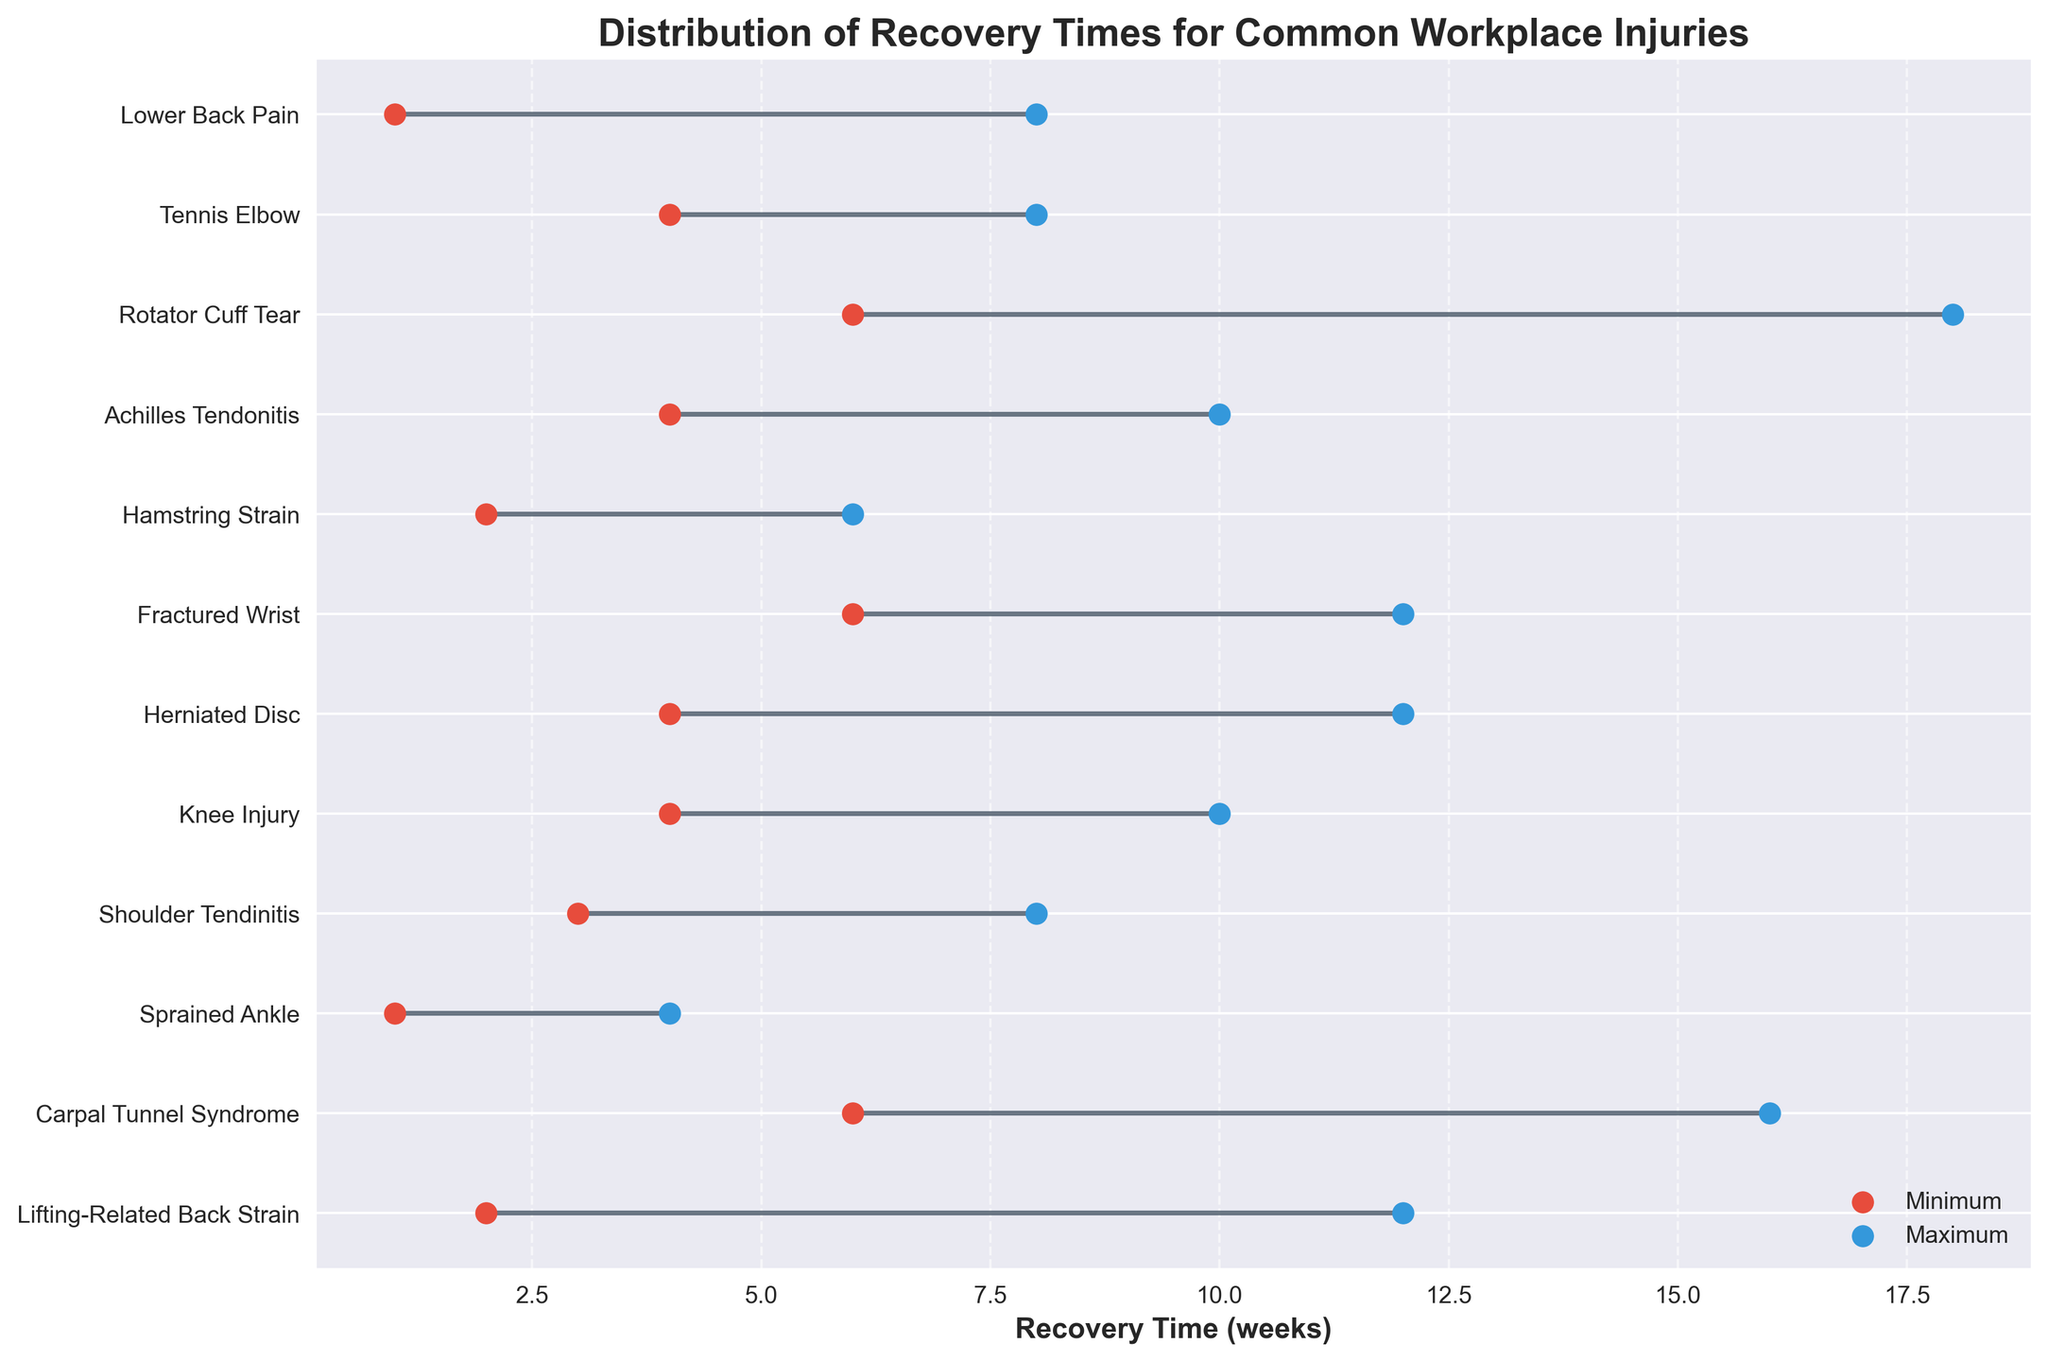What is the maximum recovery time for a rotator cuff tear? We look for the "Rotator Cuff Tear" in the y-axis labels and find the corresponding blue scatter point representing the maximum recovery time.
Answer: 18 weeks Which injury has the shortest minimum recovery time? We compare all the red scatter points, which represent the minimum recovery times, and identify the lowest point. The lowest minimum recovery time is at "Sprained Ankle".
Answer: Sprained Ankle What is the range of recovery time for carpal tunnel syndrome? The range is calculated by subtracting the minimum recovery time from the maximum recovery time for carpal tunnel syndrome.
Answer: 10 weeks How many injuries have a maximum recovery time greater than 10 weeks? We count the number of blue scatter points that are positioned beyond the 10 weeks mark on the x-axis. In this case, they are Lifting-Related Back Strain, Carpal Tunnel Syndrome, Rotator Cuff Tear, and Fractured Wrist, and Herniated Disc.
Answer: 5 injuries Which injury has the smallest range of recovery times? The smallest range can be found by identifying the injury where the difference between the maximum and minimum recovery times (the length of the horizontal line) is the shortest. This is "Sprained Ankle".
Answer: Sprained Ankle Compare the maximum recovery times for shoulder tendinitis and knee injury. Which one is longer? We locate the blue scatter points for "Shoulder Tendinitis" and "Knee Injury" and compare their x-axis positions. "Knee Injury" has a recovery time of 10 weeks, while "Shoulder Tendinitis" has 8 weeks.
Answer: Knee Injury Which injury has a larger range of recovery time: herniated disc or Achilles tendonitis? We calculate the range for both injuries by subtracting the minimum recovery time from the maximum recovery time (12-4 for Herniated Disc and 10-4 for Achilles Tendinitis) and compare. Herniated Disc has a range of 8 weeks, Achilles Tendonitis has 6 weeks.
Answer: Herniated Disc What is the median maximum recovery time for all injuries? The median is found by arranging the maximum recovery times in ascending order and finding the middle value. Max times: 4, 8, 8, 8, 10, 10, 12, 12, 12, 16, 18. The middle value here is the average of the 6th and 7th values: (10+12)/2 = 11.
Answer: 11 weeks 